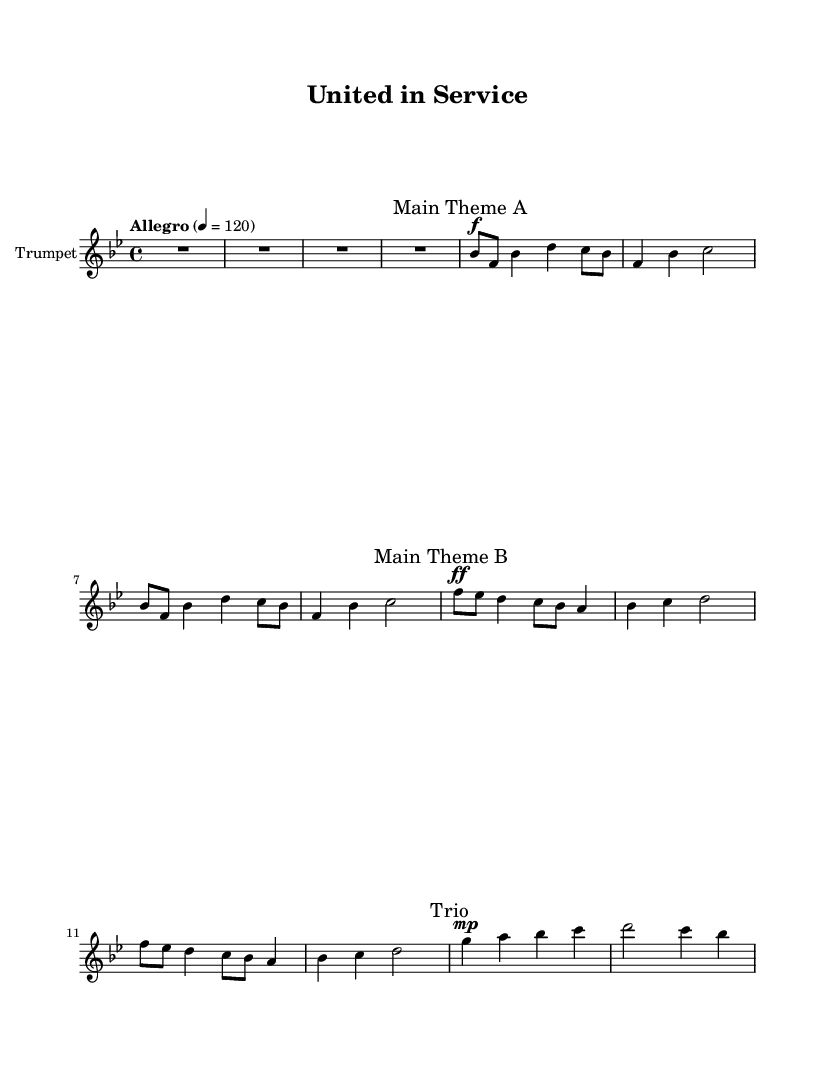What is the key signature of this music? The key signature indicated at the beginning of the score is B flat major, which has two flats.
Answer: B flat major What is the time signature of this music? The time signature shown at the beginning of the score is 4/4, meaning there are four beats in each measure.
Answer: 4/4 What is the tempo marking for this piece? The tempo marking provided in the score is "Allegro" with a metronome marking of 120 beats per minute, indicating a fast and lively pace.
Answer: Allegro, 120 How many main themes are there in this piece? The score specifies two distinct main themes, labeled as "Main Theme A" and "Main Theme B."
Answer: Two What dynamics are used in the main themes? The first theme starts with a forte dynamic marking, and the second theme uses fortissimo, indicating progressively louder dynamics.
Answer: Forte, Fortissimo What is the duration of the introduction in measures? The introduction section is indicated with a single rest (R1) for a duration of four beats, which translates to one measure.
Answer: 1 measure Which instrument is featured in this music? The score clearly states that the instrument being used is the trumpet, as noted in the staff settings.
Answer: Trumpet 